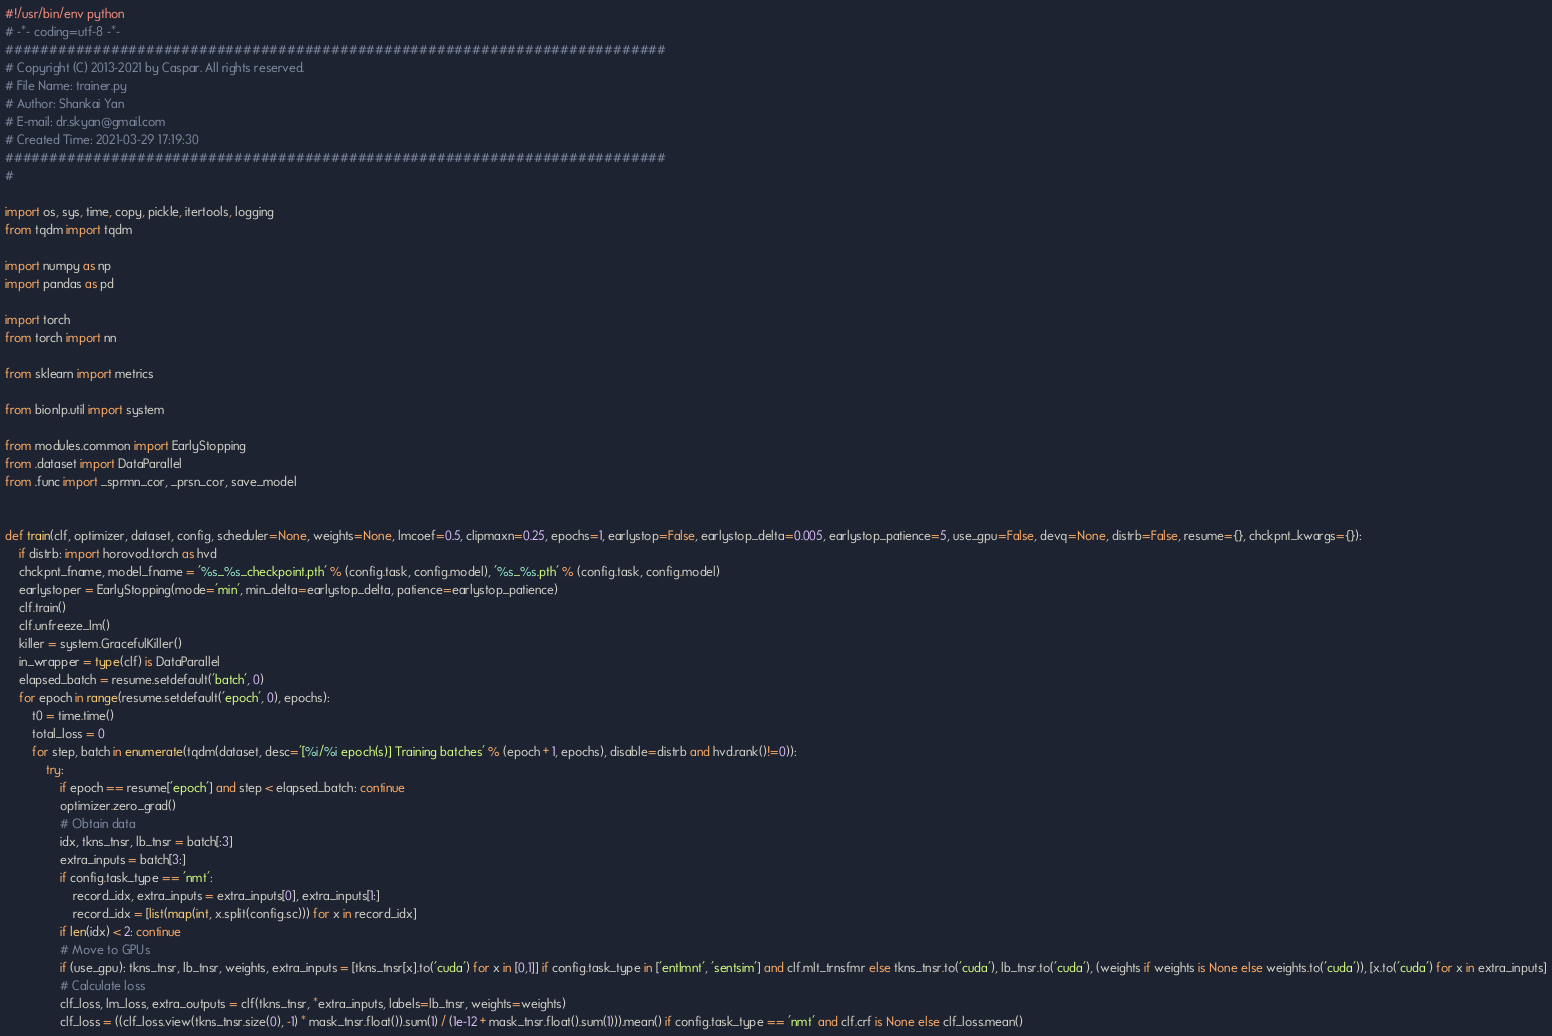<code> <loc_0><loc_0><loc_500><loc_500><_Python_>#!/usr/bin/env python
# -*- coding=utf-8 -*-
###########################################################################
# Copyright (C) 2013-2021 by Caspar. All rights reserved.
# File Name: trainer.py
# Author: Shankai Yan
# E-mail: dr.skyan@gmail.com
# Created Time: 2021-03-29 17:19:30
###########################################################################
#

import os, sys, time, copy, pickle, itertools, logging
from tqdm import tqdm

import numpy as np
import pandas as pd

import torch
from torch import nn

from sklearn import metrics

from bionlp.util import system

from modules.common import EarlyStopping
from .dataset import DataParallel
from .func import _sprmn_cor, _prsn_cor, save_model


def train(clf, optimizer, dataset, config, scheduler=None, weights=None, lmcoef=0.5, clipmaxn=0.25, epochs=1, earlystop=False, earlystop_delta=0.005, earlystop_patience=5, use_gpu=False, devq=None, distrb=False, resume={}, chckpnt_kwargs={}):
    if distrb: import horovod.torch as hvd
    chckpnt_fname, model_fname = '%s_%s_checkpoint.pth' % (config.task, config.model), '%s_%s.pth' % (config.task, config.model)
    earlystoper = EarlyStopping(mode='min', min_delta=earlystop_delta, patience=earlystop_patience)
    clf.train()
    clf.unfreeze_lm()
    killer = system.GracefulKiller()
    in_wrapper = type(clf) is DataParallel
    elapsed_batch = resume.setdefault('batch', 0)
    for epoch in range(resume.setdefault('epoch', 0), epochs):
        t0 = time.time()
        total_loss = 0
        for step, batch in enumerate(tqdm(dataset, desc='[%i/%i epoch(s)] Training batches' % (epoch + 1, epochs), disable=distrb and hvd.rank()!=0)):
            try:
                if epoch == resume['epoch'] and step < elapsed_batch: continue
                optimizer.zero_grad()
                # Obtain data
                idx, tkns_tnsr, lb_tnsr = batch[:3]
                extra_inputs = batch[3:]
                if config.task_type == 'nmt':
                    record_idx, extra_inputs = extra_inputs[0], extra_inputs[1:]
                    record_idx = [list(map(int, x.split(config.sc))) for x in record_idx]
                if len(idx) < 2: continue
                # Move to GPUs
                if (use_gpu): tkns_tnsr, lb_tnsr, weights, extra_inputs = [tkns_tnsr[x].to('cuda') for x in [0,1]] if config.task_type in ['entlmnt', 'sentsim'] and clf.mlt_trnsfmr else tkns_tnsr.to('cuda'), lb_tnsr.to('cuda'), (weights if weights is None else weights.to('cuda')), [x.to('cuda') for x in extra_inputs]
                # Calculate loss
                clf_loss, lm_loss, extra_outputs = clf(tkns_tnsr, *extra_inputs, labels=lb_tnsr, weights=weights)
                clf_loss = ((clf_loss.view(tkns_tnsr.size(0), -1) * mask_tnsr.float()).sum(1) / (1e-12 + mask_tnsr.float().sum(1))).mean() if config.task_type == 'nmt' and clf.crf is None else clf_loss.mean()</code> 